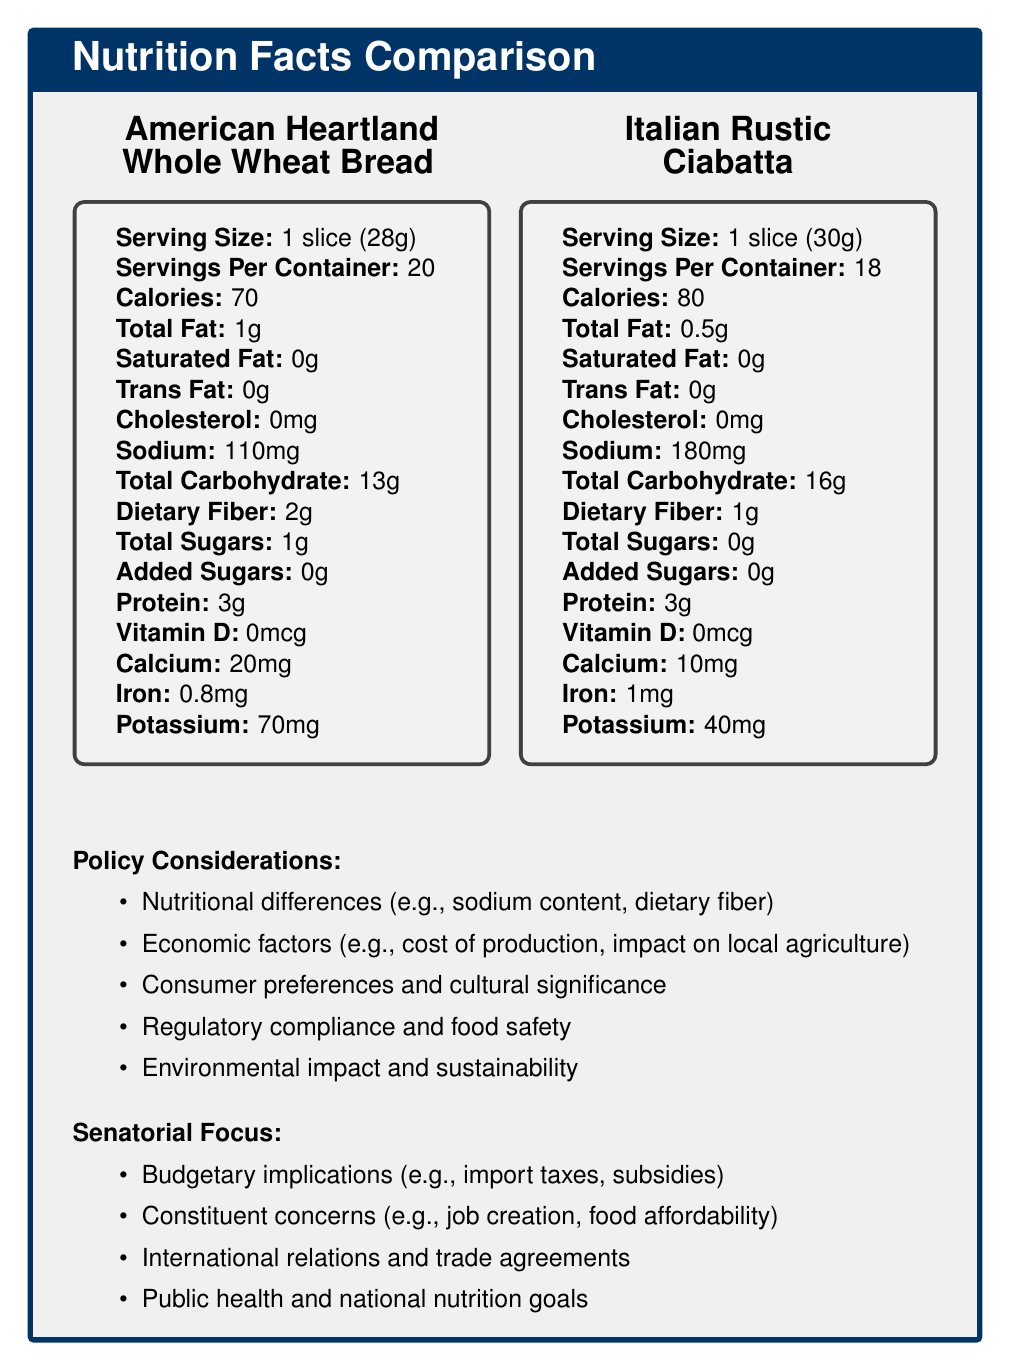what is the serving size of the American Heartland Whole Wheat Bread? The serving size is listed in the nutrition facts box for the American Heartland Whole Wheat Bread.
Answer: 1 slice (28g) how many servings are in one container of Italian Rustic Ciabatta? The servings per container are noted in the nutrition facts box for the Italian Rustic Ciabatta.
Answer: 18 which bread has more calories per serving? The Italian Rustic Ciabatta has 80 calories per serving, while the American Heartland Whole Wheat Bread has 70 calories.
Answer: Italian Rustic Ciabatta what is the total fat content in the American Heartland Whole Wheat Bread? The total fat content for the American Heartland Whole Wheat Bread is provided in the nutrition facts box.
Answer: 1g between the two breads, which one has more dietary fiber per serving? The American Heartland Whole Wheat Bread has 2g of dietary fiber per serving, whereas the Italian Rustic Ciabatta has 1g.
Answer: American Heartland Whole Wheat Bread what is the sodium content of the Italian Rustic Ciabatta? The sodium content for the Italian Rustic Ciabatta is listed as 180mg per serving.
Answer: 180mg which product has higher iron content? A. American Heartland Whole Wheat Bread B. Italian Rustic Ciabatta The Italian Rustic Ciabatta has 1mg of iron per serving, while the American Heartland Whole Wheat Bread has 0.8mg.
Answer: B. Italian Rustic Ciabatta how much calcium does the American Heartland Whole Wheat Bread contain? The calcium content for the American Heartland Whole Wheat Bread is listed as 20mg per serving.
Answer: 20mg which bread contains added sugars? A. American Heartland Whole Wheat Bread B. Italian Rustic Ciabatta C. Both D. Neither Neither bread contains added sugars as both have 0g listed for added sugars.
Answer: D. Neither is the total carbohydrate content higher in the imported or domestic product? The Italian Rustic Ciabatta, the imported product, has 16g of total carbohydrates per serving compared to 13g in the American Heartland Whole Wheat Bread.
Answer: Imported product does the American Heartland Whole Wheat Bread contain any cholesterol? The American Heartland Whole Wheat Bread contains 0mg of cholesterol.
Answer: No describe the main idea of the document. The main idea is to compare the nutritional content of domestically produced and imported bread, while considering relevant policy factors that could influence trade decisions.
Answer: The document presents a comparison of the nutrition facts labels for two bread products, one domestic (American Heartland Whole Wheat Bread) and one imported (Italian Rustic Ciabatta). It highlights differences in nutritional content such as calories, fat, sodium, fiber, sugars, protein, and vitamins/minerals. The document also outlines key policy considerations in trade policy decisions, including nutritional differences, economic factors, consumer preferences, regulatory compliance, and environmental impact. how will trade agreements impact these products? The document does not provide specific details on how trade agreements will impact the American Heartland Whole Wheat Bread and Italian Rustic Ciabatta.
Answer: Not enough information do both bread products list the same serving size? The American Heartland Whole Wheat Bread lists a serving size of 1 slice (28g) while the Italian Rustic Ciabatta lists a serving size of 1 slice (30g).
Answer: No 